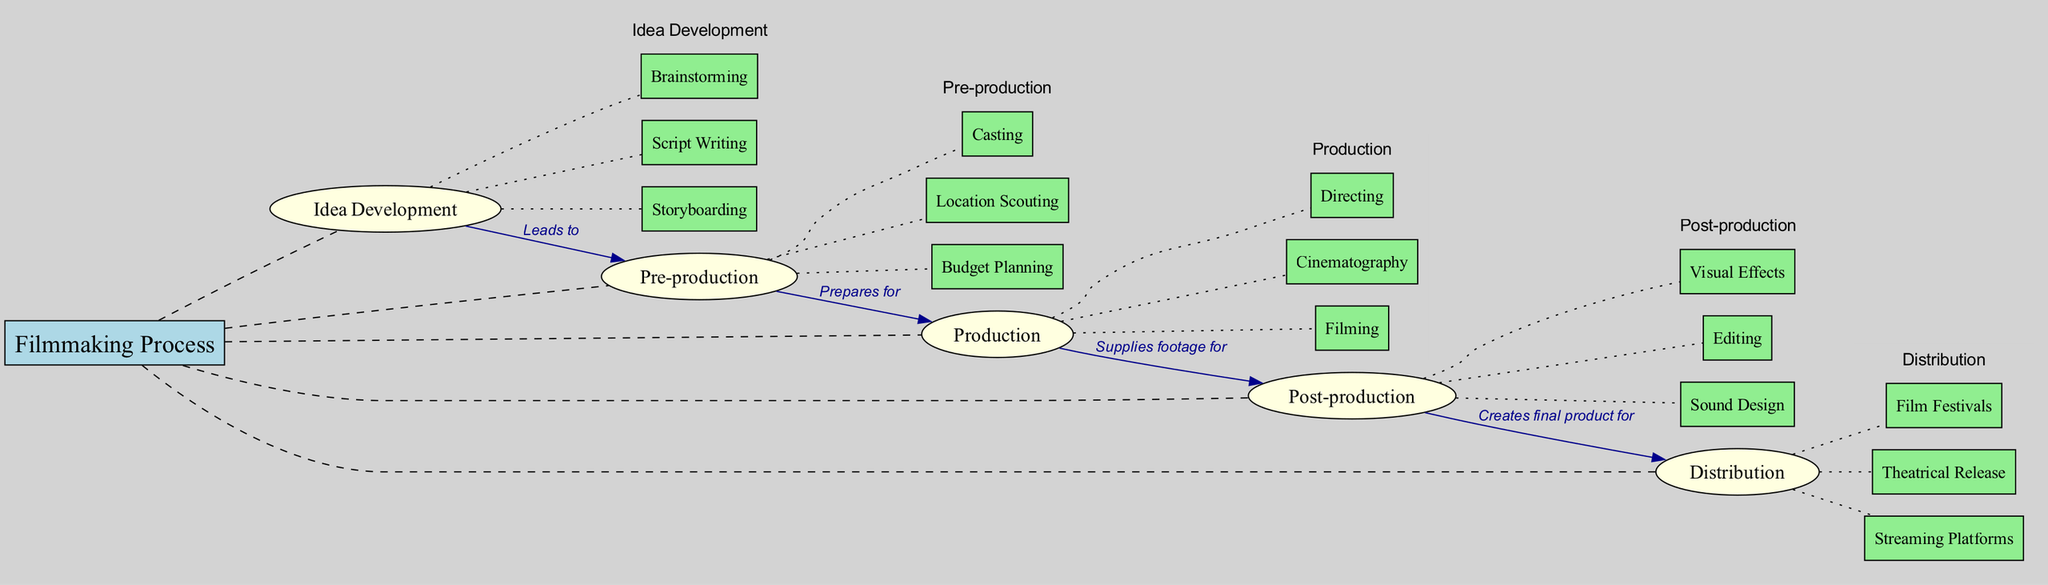What are the main nodes in the filmmaking process? The main nodes are listed in the diagram as separate branches connecting to the central concept "Filmmaking Process". These nodes include "Idea Development", "Pre-production", "Production", "Post-production", and "Distribution".
Answer: Idea Development, Pre-production, Production, Post-production, Distribution How many sub-nodes are there under "Pre-production"? Under the main node "Pre-production", there are three sub-nodes: "Casting", "Location Scouting", and "Budget Planning". Counting these gives a total of three sub-nodes.
Answer: 3 What does "Production" supply to "Post-production"? According to the connection labeled "Supplies footage for", the diagram indicates that the "Production" phase supplies footage to "Post-production". This label directly indicates the relationship between these two nodes.
Answer: Footage Which phase of filmmaking leads to "Pre-production"? The diagram clearly states that "Idea Development" leads to "Pre-production", as indicated by the connecting label "Leads to". This highlights the flow from generating an idea to preparing for the film.
Answer: Idea Development What is the relationship between "Post-production" and "Distribution"? The diagram shows that "Post-production" creates the final product for "Distribution", as indicated by the connecting label "Creates final product for". This relationship defines the output of the post-production work being ready for distribution.
Answer: Creates final product for How many nodes are connected directly to "Post-production"? Examining the diagram, "Post-production" has three sub-nodes connected directly: "Editing", "Sound Design", and "Visual Effects". Thus, there are three direct connections to "Post-production".
Answer: 3 What is the last phase in the filmmaking process? The diagram indicates that the last phase in the sequence is "Distribution", which follows "Post-production" and is ultimately the phase where the final product is made available to audiences.
Answer: Distribution Which sub-node is related to the task of preparing a budget? The sub-node "Budget Planning" is specifically mentioned under "Pre-production". This sub-node captures the essential task of financial preparation prior to filming, as showcased in the diagram.
Answer: Budget Planning 